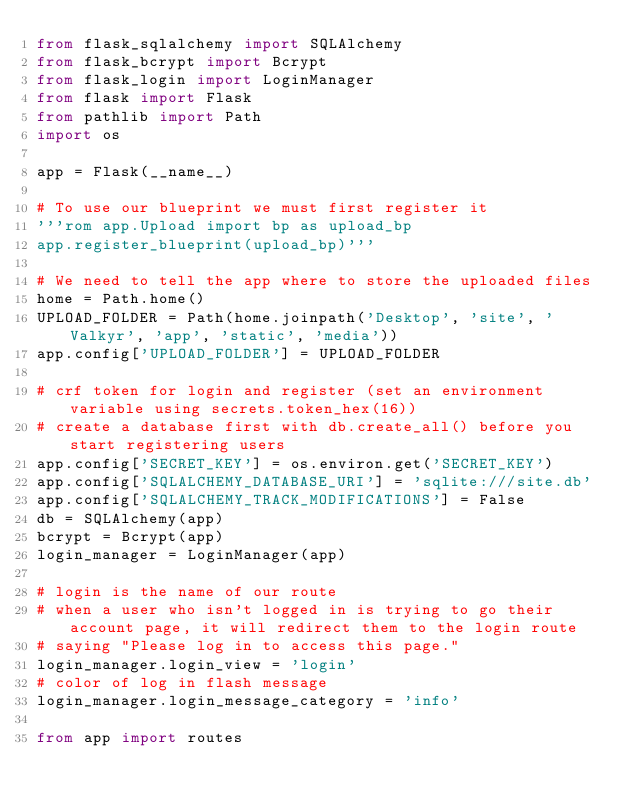Convert code to text. <code><loc_0><loc_0><loc_500><loc_500><_Python_>from flask_sqlalchemy import SQLAlchemy
from flask_bcrypt import Bcrypt
from flask_login import LoginManager
from flask import Flask
from pathlib import Path
import os

app = Flask(__name__)

# To use our blueprint we must first register it
'''rom app.Upload import bp as upload_bp
app.register_blueprint(upload_bp)'''

# We need to tell the app where to store the uploaded files
home = Path.home()
UPLOAD_FOLDER = Path(home.joinpath('Desktop', 'site', 'Valkyr', 'app', 'static', 'media'))
app.config['UPLOAD_FOLDER'] = UPLOAD_FOLDER

# crf token for login and register (set an environment variable using secrets.token_hex(16))
# create a database first with db.create_all() before you start registering users 
app.config['SECRET_KEY'] = os.environ.get('SECRET_KEY')
app.config['SQLALCHEMY_DATABASE_URI'] = 'sqlite:///site.db'
app.config['SQLALCHEMY_TRACK_MODIFICATIONS'] = False
db = SQLAlchemy(app)
bcrypt = Bcrypt(app)
login_manager = LoginManager(app)

# login is the name of our route 
# when a user who isn't logged in is trying to go their account page, it will redirect them to the login route
# saying "Please log in to access this page."
login_manager.login_view = 'login'
# color of log in flash message 
login_manager.login_message_category = 'info'

from app import routes


</code> 